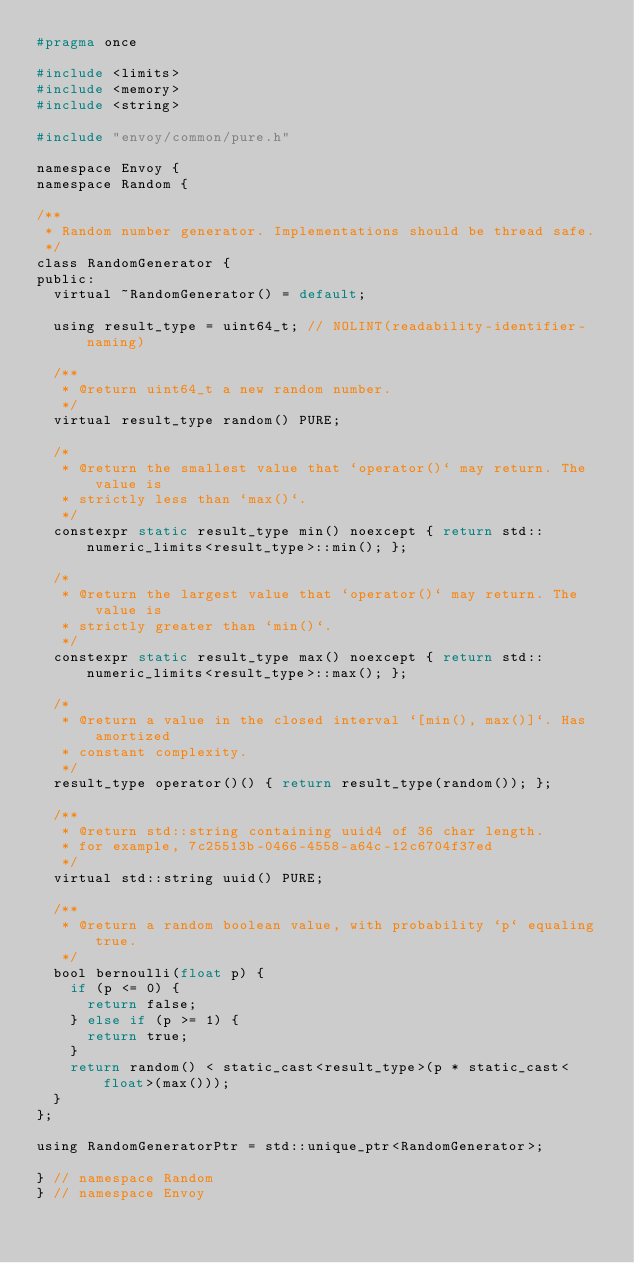Convert code to text. <code><loc_0><loc_0><loc_500><loc_500><_C_>#pragma once

#include <limits>
#include <memory>
#include <string>

#include "envoy/common/pure.h"

namespace Envoy {
namespace Random {

/**
 * Random number generator. Implementations should be thread safe.
 */
class RandomGenerator {
public:
  virtual ~RandomGenerator() = default;

  using result_type = uint64_t; // NOLINT(readability-identifier-naming)

  /**
   * @return uint64_t a new random number.
   */
  virtual result_type random() PURE;

  /*
   * @return the smallest value that `operator()` may return. The value is
   * strictly less than `max()`.
   */
  constexpr static result_type min() noexcept { return std::numeric_limits<result_type>::min(); };

  /*
   * @return the largest value that `operator()` may return. The value is
   * strictly greater than `min()`.
   */
  constexpr static result_type max() noexcept { return std::numeric_limits<result_type>::max(); };

  /*
   * @return a value in the closed interval `[min(), max()]`. Has amortized
   * constant complexity.
   */
  result_type operator()() { return result_type(random()); };

  /**
   * @return std::string containing uuid4 of 36 char length.
   * for example, 7c25513b-0466-4558-a64c-12c6704f37ed
   */
  virtual std::string uuid() PURE;

  /**
   * @return a random boolean value, with probability `p` equaling true.
   */
  bool bernoulli(float p) {
    if (p <= 0) {
      return false;
    } else if (p >= 1) {
      return true;
    }
    return random() < static_cast<result_type>(p * static_cast<float>(max()));
  }
};

using RandomGeneratorPtr = std::unique_ptr<RandomGenerator>;

} // namespace Random
} // namespace Envoy
</code> 